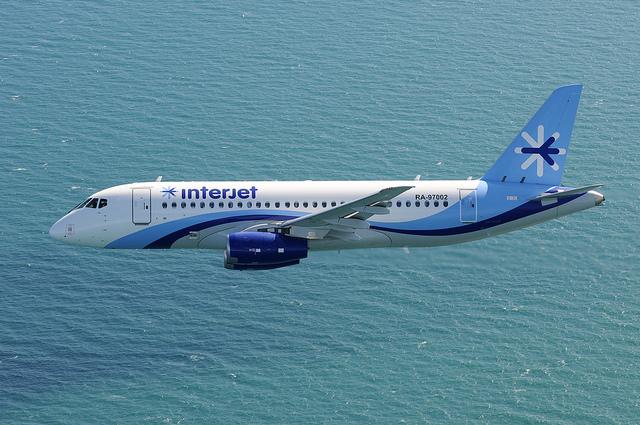Is any land visible in this image?
Concise answer only. No. Where would this plane be going?
Answer briefly. Airport. What is the plane flying over?
Concise answer only. Water. 